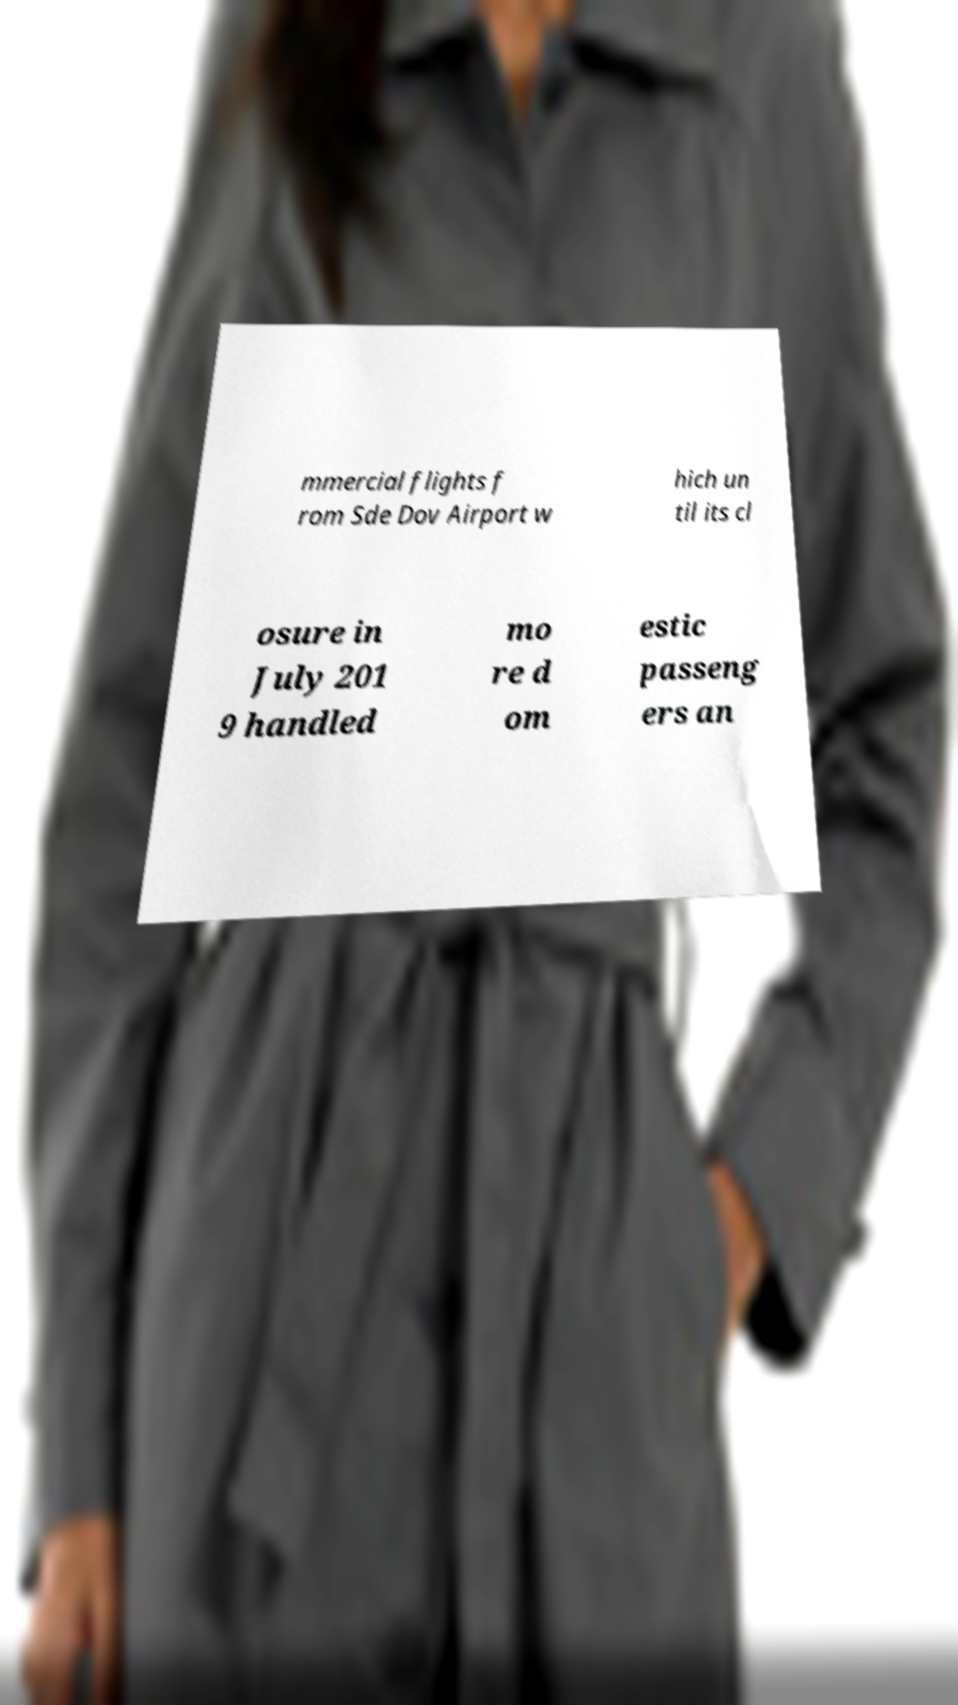Please read and relay the text visible in this image. What does it say? mmercial flights f rom Sde Dov Airport w hich un til its cl osure in July 201 9 handled mo re d om estic passeng ers an 